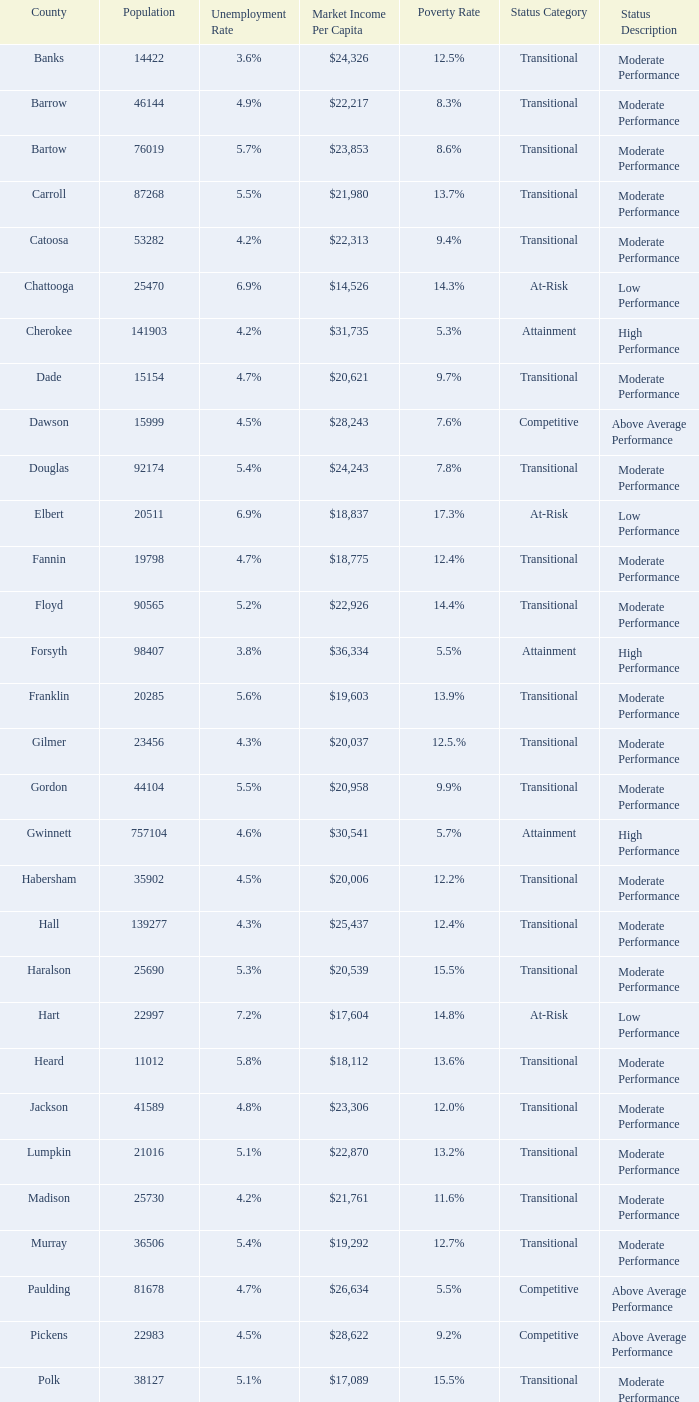What is the unemployment rate for the county with a market income per capita of $20,958? 1.0. 